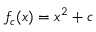<formula> <loc_0><loc_0><loc_500><loc_500>f _ { c } ( x ) = x ^ { 2 } + c</formula> 